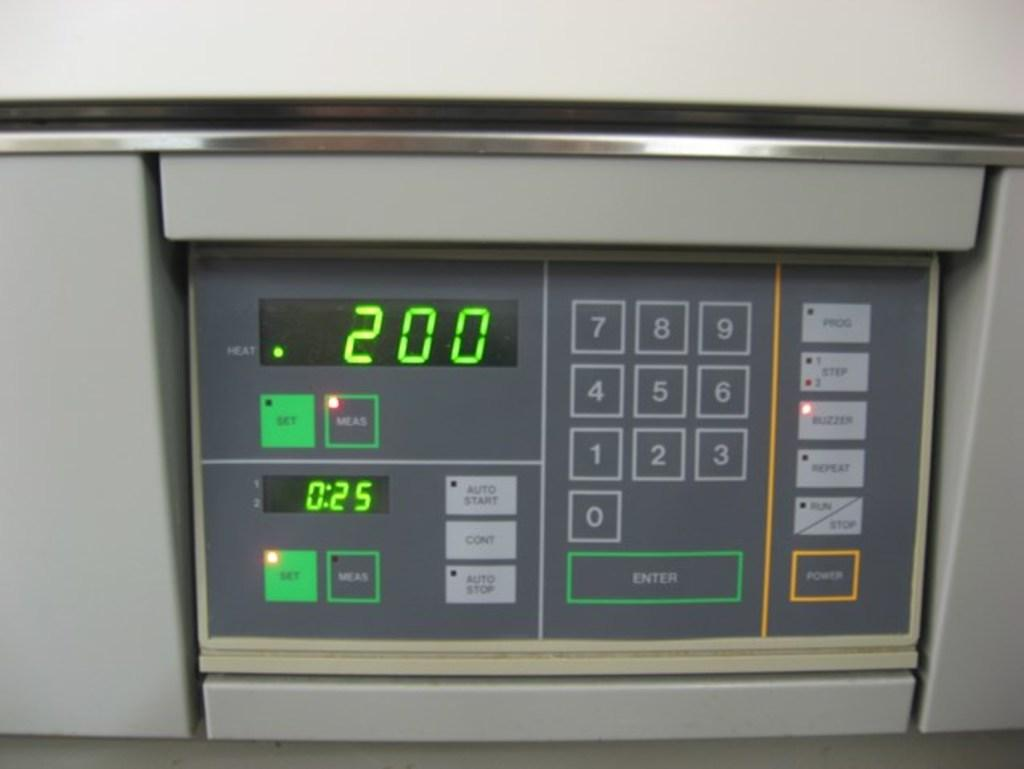What type of object is the main subject in the image? There is an electronic device in the image. What type of vessel is being used by the maid in the image? There is no vessel or maid present in the image; it only features an electronic device. 